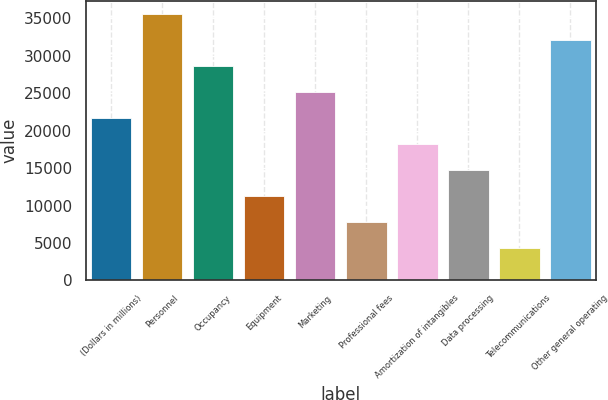Convert chart. <chart><loc_0><loc_0><loc_500><loc_500><bar_chart><fcel>(Dollars in millions)<fcel>Personnel<fcel>Occupancy<fcel>Equipment<fcel>Marketing<fcel>Professional fees<fcel>Amortization of intangibles<fcel>Data processing<fcel>Telecommunications<fcel>Other general operating<nl><fcel>21680.2<fcel>35597<fcel>28638.6<fcel>11242.6<fcel>25159.4<fcel>7763.4<fcel>18201<fcel>14721.8<fcel>4284.2<fcel>32117.8<nl></chart> 